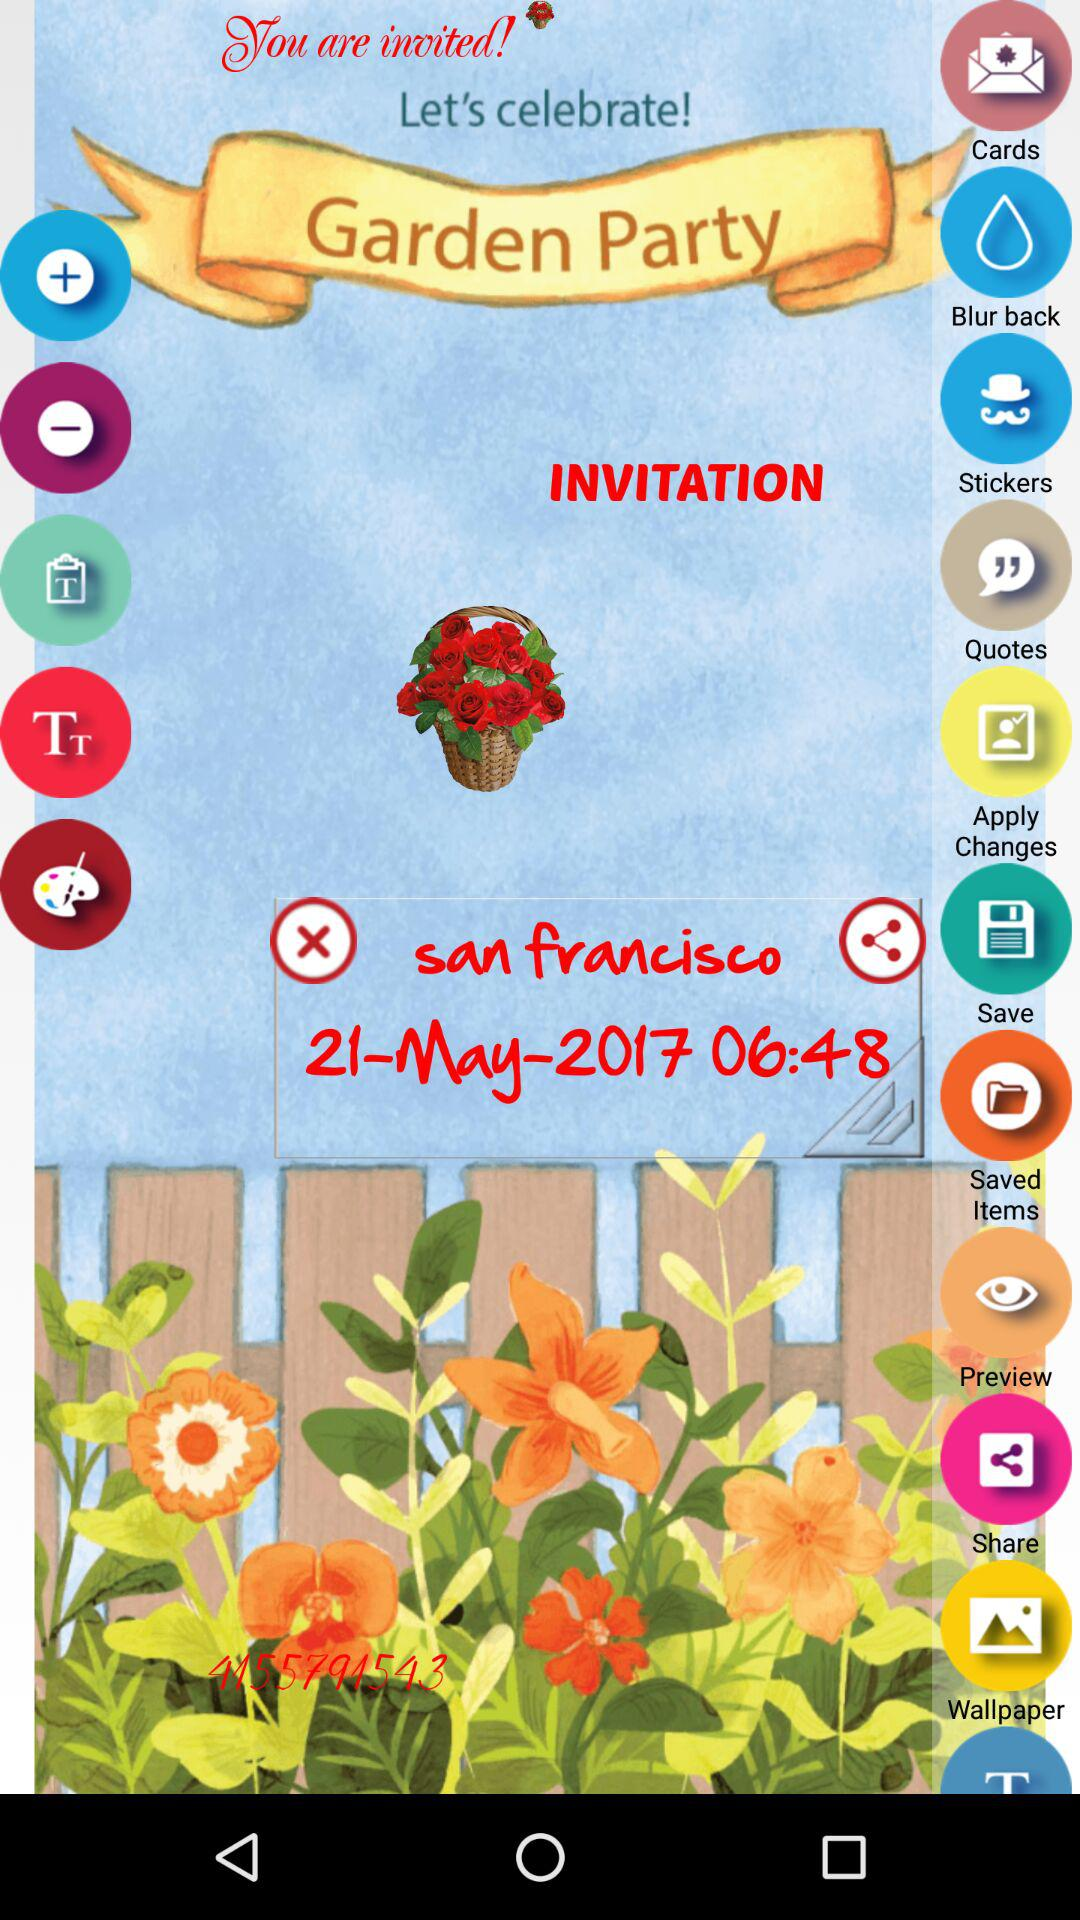On what date will the party be organized? The party will be organized on May 21, 2017. 